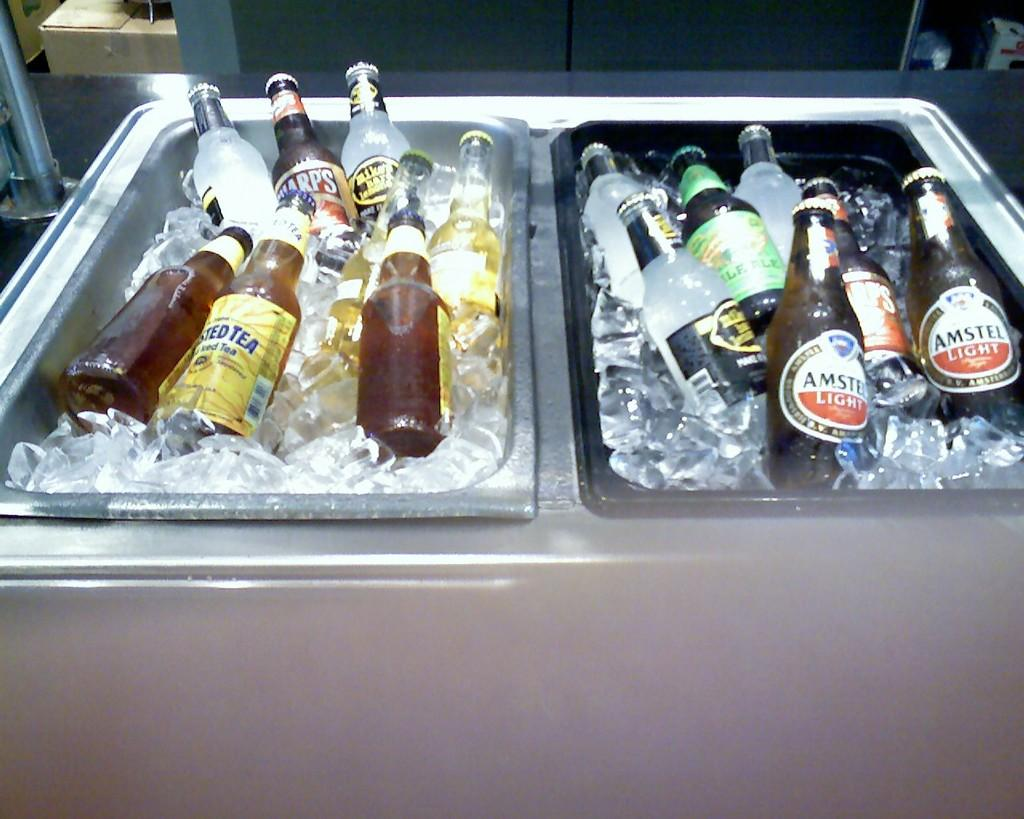Provide a one-sentence caption for the provided image. Amstel Light Beer and Mike's lemoade alcohol in a freezer. 